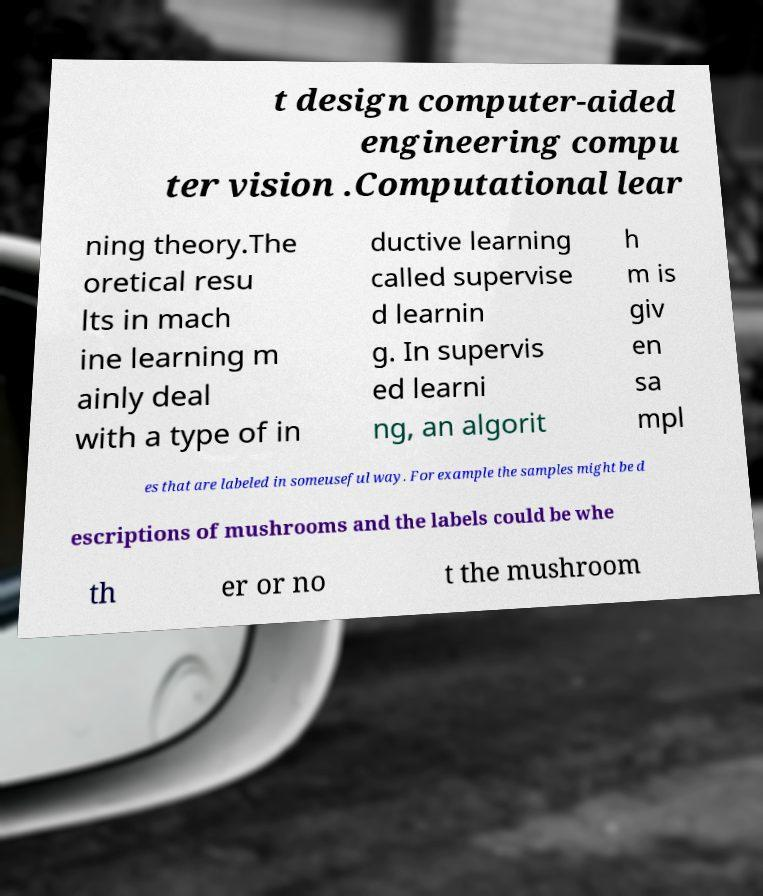Please read and relay the text visible in this image. What does it say? t design computer-aided engineering compu ter vision .Computational lear ning theory.The oretical resu lts in mach ine learning m ainly deal with a type of in ductive learning called supervise d learnin g. In supervis ed learni ng, an algorit h m is giv en sa mpl es that are labeled in someuseful way. For example the samples might be d escriptions of mushrooms and the labels could be whe th er or no t the mushroom 